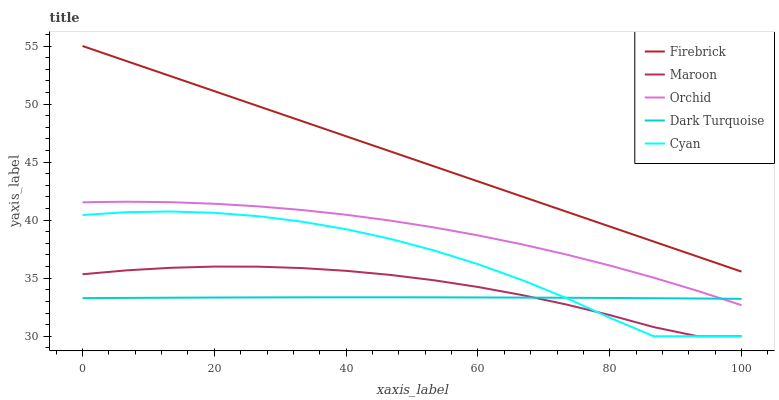Does Dark Turquoise have the minimum area under the curve?
Answer yes or no. Yes. Does Firebrick have the maximum area under the curve?
Answer yes or no. Yes. Does Cyan have the minimum area under the curve?
Answer yes or no. No. Does Cyan have the maximum area under the curve?
Answer yes or no. No. Is Firebrick the smoothest?
Answer yes or no. Yes. Is Cyan the roughest?
Answer yes or no. Yes. Is Cyan the smoothest?
Answer yes or no. No. Is Firebrick the roughest?
Answer yes or no. No. Does Cyan have the lowest value?
Answer yes or no. Yes. Does Firebrick have the lowest value?
Answer yes or no. No. Does Firebrick have the highest value?
Answer yes or no. Yes. Does Cyan have the highest value?
Answer yes or no. No. Is Cyan less than Firebrick?
Answer yes or no. Yes. Is Firebrick greater than Cyan?
Answer yes or no. Yes. Does Orchid intersect Dark Turquoise?
Answer yes or no. Yes. Is Orchid less than Dark Turquoise?
Answer yes or no. No. Is Orchid greater than Dark Turquoise?
Answer yes or no. No. Does Cyan intersect Firebrick?
Answer yes or no. No. 